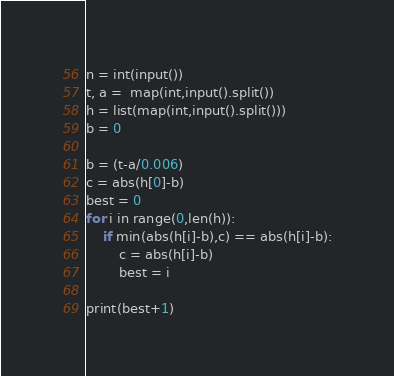<code> <loc_0><loc_0><loc_500><loc_500><_Python_>n = int(input())
t, a =  map(int,input().split())
h = list(map(int,input().split()))
b = 0

b = (t-a/0.006)
c = abs(h[0]-b)
best = 0
for i in range(0,len(h)):
    if min(abs(h[i]-b),c) == abs(h[i]-b):
        c = abs(h[i]-b)
        best = i

print(best+1)</code> 